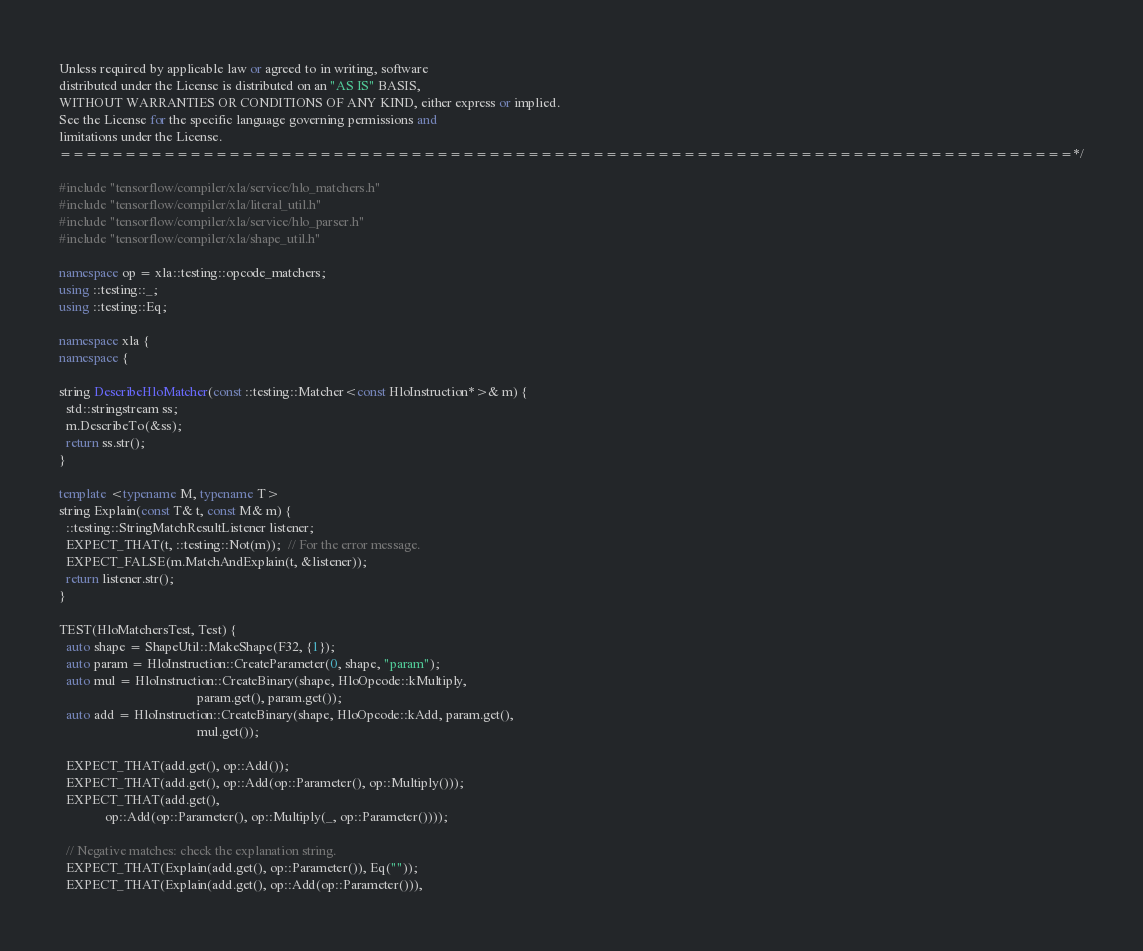<code> <loc_0><loc_0><loc_500><loc_500><_C++_>
Unless required by applicable law or agreed to in writing, software
distributed under the License is distributed on an "AS IS" BASIS,
WITHOUT WARRANTIES OR CONDITIONS OF ANY KIND, either express or implied.
See the License for the specific language governing permissions and
limitations under the License.
==============================================================================*/

#include "tensorflow/compiler/xla/service/hlo_matchers.h"
#include "tensorflow/compiler/xla/literal_util.h"
#include "tensorflow/compiler/xla/service/hlo_parser.h"
#include "tensorflow/compiler/xla/shape_util.h"

namespace op = xla::testing::opcode_matchers;
using ::testing::_;
using ::testing::Eq;

namespace xla {
namespace {

string DescribeHloMatcher(const ::testing::Matcher<const HloInstruction*>& m) {
  std::stringstream ss;
  m.DescribeTo(&ss);
  return ss.str();
}

template <typename M, typename T>
string Explain(const T& t, const M& m) {
  ::testing::StringMatchResultListener listener;
  EXPECT_THAT(t, ::testing::Not(m));  // For the error message.
  EXPECT_FALSE(m.MatchAndExplain(t, &listener));
  return listener.str();
}

TEST(HloMatchersTest, Test) {
  auto shape = ShapeUtil::MakeShape(F32, {1});
  auto param = HloInstruction::CreateParameter(0, shape, "param");
  auto mul = HloInstruction::CreateBinary(shape, HloOpcode::kMultiply,
                                          param.get(), param.get());
  auto add = HloInstruction::CreateBinary(shape, HloOpcode::kAdd, param.get(),
                                          mul.get());

  EXPECT_THAT(add.get(), op::Add());
  EXPECT_THAT(add.get(), op::Add(op::Parameter(), op::Multiply()));
  EXPECT_THAT(add.get(),
              op::Add(op::Parameter(), op::Multiply(_, op::Parameter())));

  // Negative matches: check the explanation string.
  EXPECT_THAT(Explain(add.get(), op::Parameter()), Eq(""));
  EXPECT_THAT(Explain(add.get(), op::Add(op::Parameter())),</code> 